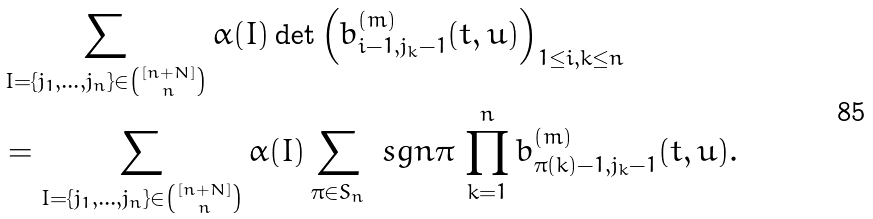<formula> <loc_0><loc_0><loc_500><loc_500>& \sum _ { I = \{ j _ { 1 } , \dots , j _ { n } \} \in \binom { [ n + N ] } { n } } \alpha ( I ) \det \left ( { b ^ { ( m ) } _ { i - 1 , j _ { k } - 1 } } ( t , u ) \right ) _ { 1 \leq i , k \leq n } \\ & = \sum _ { I = \{ j _ { 1 } , \dots , j _ { n } \} \in \binom { [ n + N ] } { n } } \alpha ( I ) \sum _ { \pi \in S _ { n } } \ s g n \pi \, \prod _ { k = 1 } ^ { n } b ^ { ( m ) } _ { \pi ( k ) - 1 , j _ { k } - 1 } ( t , u ) .</formula> 